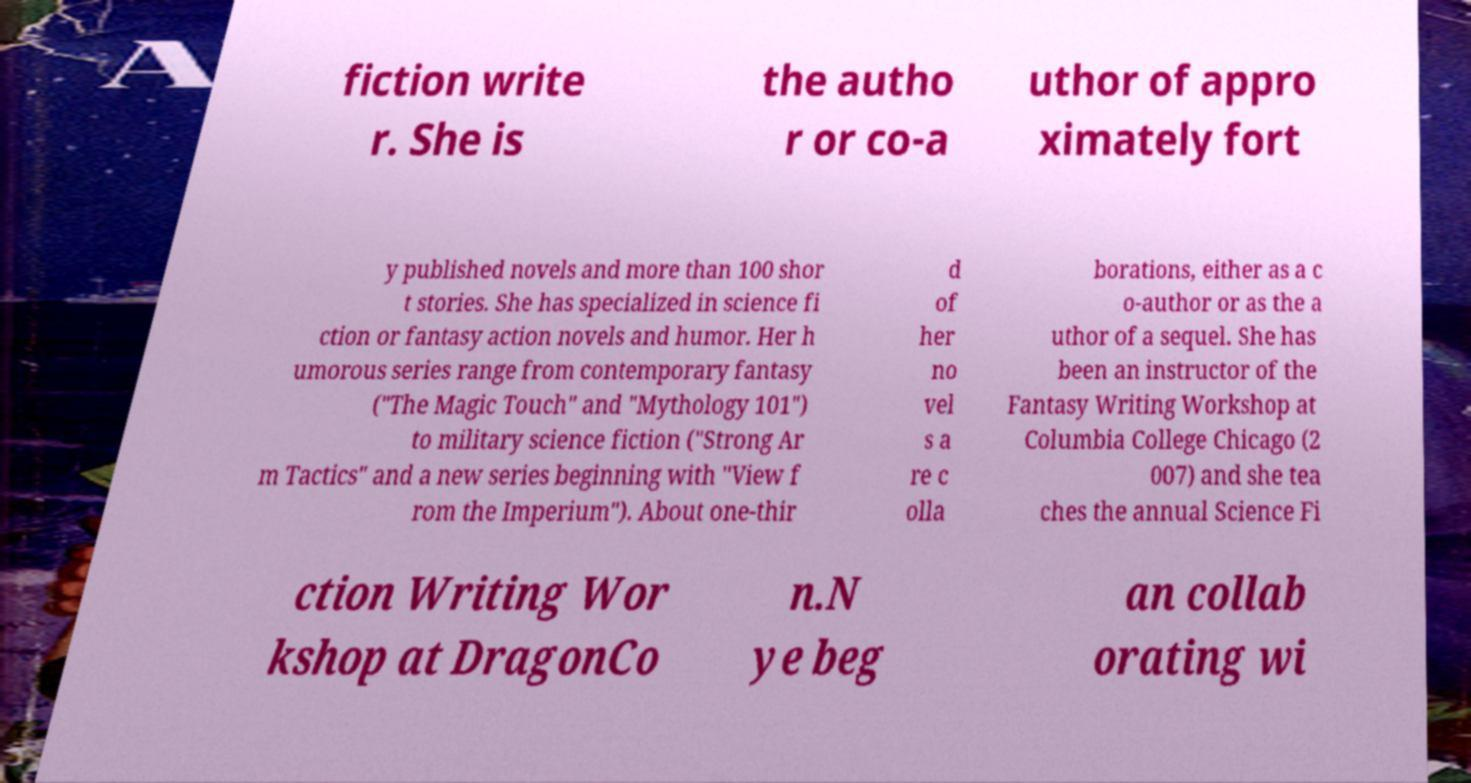Can you read and provide the text displayed in the image?This photo seems to have some interesting text. Can you extract and type it out for me? fiction write r. She is the autho r or co-a uthor of appro ximately fort y published novels and more than 100 shor t stories. She has specialized in science fi ction or fantasy action novels and humor. Her h umorous series range from contemporary fantasy ("The Magic Touch" and "Mythology 101") to military science fiction ("Strong Ar m Tactics" and a new series beginning with "View f rom the Imperium"). About one-thir d of her no vel s a re c olla borations, either as a c o-author or as the a uthor of a sequel. She has been an instructor of the Fantasy Writing Workshop at Columbia College Chicago (2 007) and she tea ches the annual Science Fi ction Writing Wor kshop at DragonCo n.N ye beg an collab orating wi 